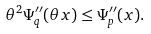<formula> <loc_0><loc_0><loc_500><loc_500>\theta ^ { 2 } \Psi _ { q } ^ { \prime \prime } ( \theta x ) \leq \Psi _ { p } ^ { \prime \prime } ( x ) .</formula> 